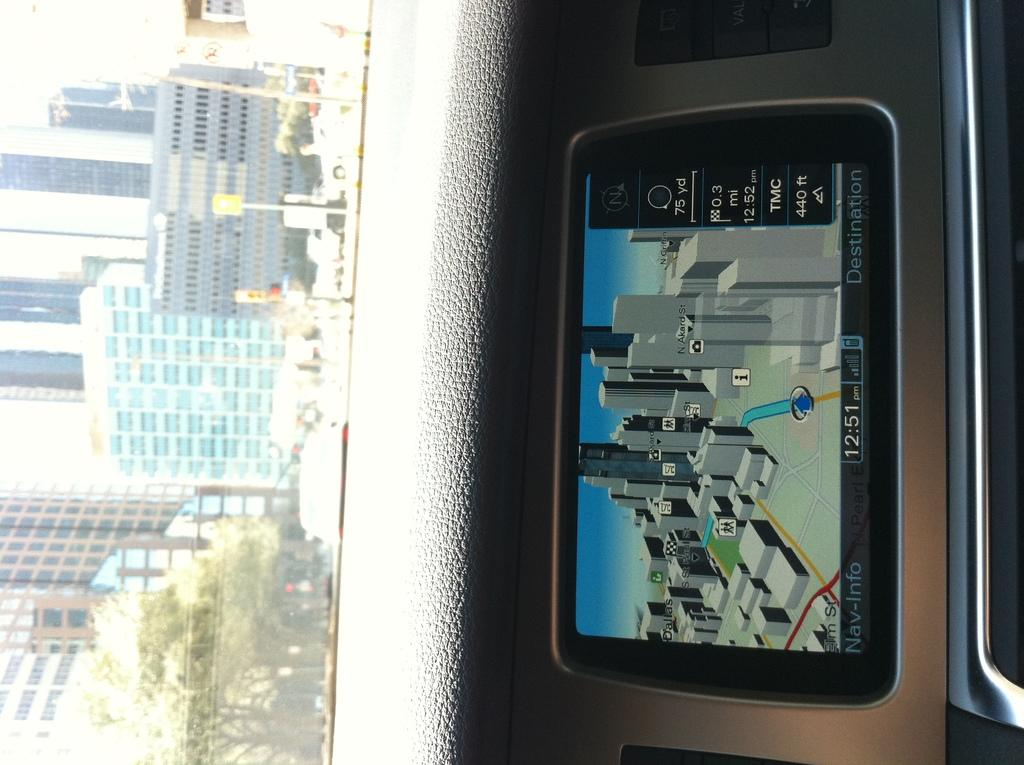<image>
Summarize the visual content of the image. Dashboard with a screen showing the time at 12:51. 